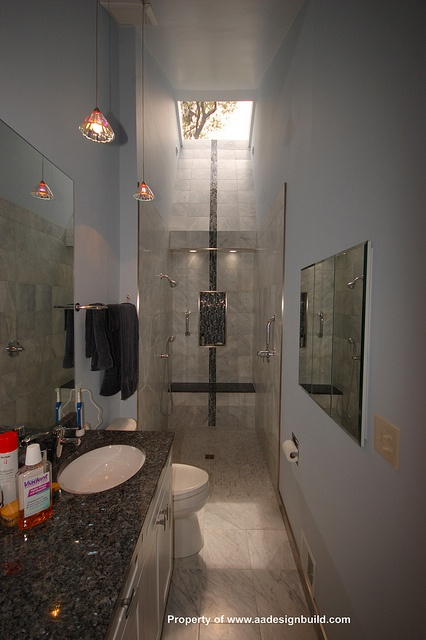Describe the objects in this image and their specific colors. I can see toilet in black, gray, and tan tones, sink in black, gray, and darkgray tones, bottle in black, gray, maroon, and darkgray tones, toothbrush in black and gray tones, and toothbrush in black, navy, and gray tones in this image. 